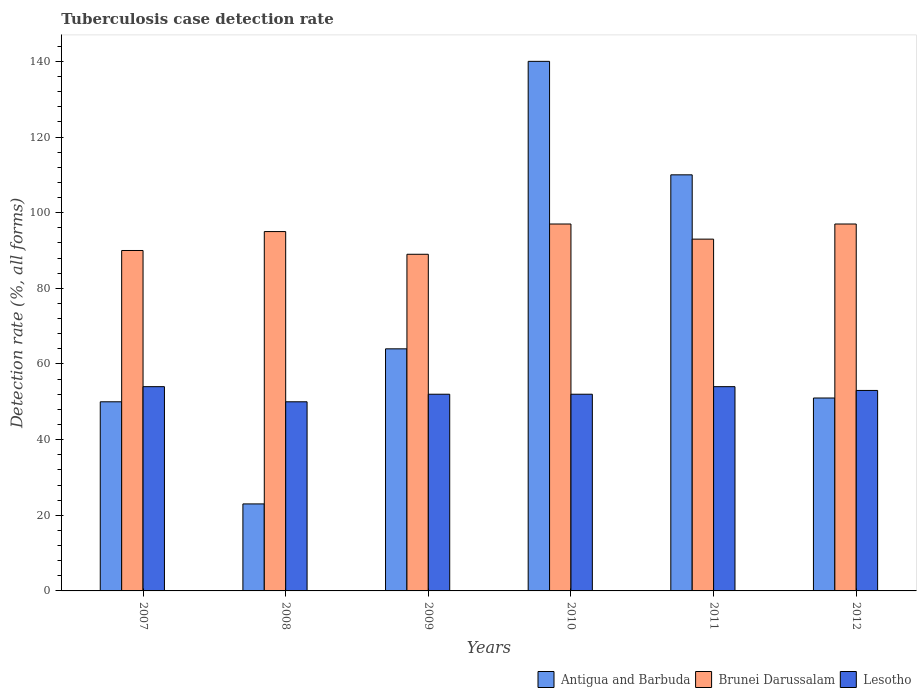How many different coloured bars are there?
Make the answer very short. 3. How many groups of bars are there?
Your answer should be compact. 6. Are the number of bars on each tick of the X-axis equal?
Offer a very short reply. Yes. How many bars are there on the 4th tick from the left?
Your response must be concise. 3. How many bars are there on the 3rd tick from the right?
Ensure brevity in your answer.  3. What is the label of the 1st group of bars from the left?
Give a very brief answer. 2007. In how many cases, is the number of bars for a given year not equal to the number of legend labels?
Your answer should be compact. 0. What is the tuberculosis case detection rate in in Lesotho in 2010?
Give a very brief answer. 52. Across all years, what is the maximum tuberculosis case detection rate in in Brunei Darussalam?
Make the answer very short. 97. Across all years, what is the minimum tuberculosis case detection rate in in Brunei Darussalam?
Keep it short and to the point. 89. In which year was the tuberculosis case detection rate in in Lesotho minimum?
Your response must be concise. 2008. What is the total tuberculosis case detection rate in in Antigua and Barbuda in the graph?
Ensure brevity in your answer.  438. What is the difference between the tuberculosis case detection rate in in Antigua and Barbuda in 2011 and that in 2012?
Give a very brief answer. 59. What is the difference between the tuberculosis case detection rate in in Lesotho in 2010 and the tuberculosis case detection rate in in Antigua and Barbuda in 2009?
Your answer should be very brief. -12. What is the average tuberculosis case detection rate in in Antigua and Barbuda per year?
Ensure brevity in your answer.  73. In the year 2008, what is the difference between the tuberculosis case detection rate in in Antigua and Barbuda and tuberculosis case detection rate in in Brunei Darussalam?
Your response must be concise. -72. What is the ratio of the tuberculosis case detection rate in in Brunei Darussalam in 2009 to that in 2010?
Keep it short and to the point. 0.92. Is the tuberculosis case detection rate in in Lesotho in 2009 less than that in 2012?
Provide a succinct answer. Yes. Is the difference between the tuberculosis case detection rate in in Antigua and Barbuda in 2010 and 2011 greater than the difference between the tuberculosis case detection rate in in Brunei Darussalam in 2010 and 2011?
Your answer should be very brief. Yes. What is the difference between the highest and the second highest tuberculosis case detection rate in in Brunei Darussalam?
Make the answer very short. 0. What is the difference between the highest and the lowest tuberculosis case detection rate in in Antigua and Barbuda?
Make the answer very short. 117. Is the sum of the tuberculosis case detection rate in in Brunei Darussalam in 2008 and 2010 greater than the maximum tuberculosis case detection rate in in Lesotho across all years?
Provide a succinct answer. Yes. What does the 1st bar from the left in 2012 represents?
Offer a very short reply. Antigua and Barbuda. What does the 1st bar from the right in 2009 represents?
Give a very brief answer. Lesotho. Is it the case that in every year, the sum of the tuberculosis case detection rate in in Antigua and Barbuda and tuberculosis case detection rate in in Brunei Darussalam is greater than the tuberculosis case detection rate in in Lesotho?
Keep it short and to the point. Yes. How many bars are there?
Offer a terse response. 18. How many years are there in the graph?
Provide a succinct answer. 6. What is the difference between two consecutive major ticks on the Y-axis?
Offer a terse response. 20. Are the values on the major ticks of Y-axis written in scientific E-notation?
Your response must be concise. No. Does the graph contain grids?
Provide a short and direct response. No. Where does the legend appear in the graph?
Your answer should be compact. Bottom right. How many legend labels are there?
Your answer should be compact. 3. How are the legend labels stacked?
Provide a short and direct response. Horizontal. What is the title of the graph?
Offer a very short reply. Tuberculosis case detection rate. Does "Uruguay" appear as one of the legend labels in the graph?
Provide a succinct answer. No. What is the label or title of the Y-axis?
Your response must be concise. Detection rate (%, all forms). What is the Detection rate (%, all forms) of Antigua and Barbuda in 2007?
Your response must be concise. 50. What is the Detection rate (%, all forms) in Lesotho in 2007?
Your response must be concise. 54. What is the Detection rate (%, all forms) in Brunei Darussalam in 2008?
Give a very brief answer. 95. What is the Detection rate (%, all forms) of Antigua and Barbuda in 2009?
Give a very brief answer. 64. What is the Detection rate (%, all forms) of Brunei Darussalam in 2009?
Give a very brief answer. 89. What is the Detection rate (%, all forms) in Lesotho in 2009?
Offer a terse response. 52. What is the Detection rate (%, all forms) in Antigua and Barbuda in 2010?
Make the answer very short. 140. What is the Detection rate (%, all forms) in Brunei Darussalam in 2010?
Your answer should be compact. 97. What is the Detection rate (%, all forms) of Lesotho in 2010?
Ensure brevity in your answer.  52. What is the Detection rate (%, all forms) of Antigua and Barbuda in 2011?
Your answer should be compact. 110. What is the Detection rate (%, all forms) of Brunei Darussalam in 2011?
Provide a short and direct response. 93. What is the Detection rate (%, all forms) of Antigua and Barbuda in 2012?
Keep it short and to the point. 51. What is the Detection rate (%, all forms) of Brunei Darussalam in 2012?
Your answer should be very brief. 97. What is the Detection rate (%, all forms) of Lesotho in 2012?
Give a very brief answer. 53. Across all years, what is the maximum Detection rate (%, all forms) in Antigua and Barbuda?
Make the answer very short. 140. Across all years, what is the maximum Detection rate (%, all forms) in Brunei Darussalam?
Make the answer very short. 97. Across all years, what is the minimum Detection rate (%, all forms) in Antigua and Barbuda?
Make the answer very short. 23. Across all years, what is the minimum Detection rate (%, all forms) of Brunei Darussalam?
Make the answer very short. 89. Across all years, what is the minimum Detection rate (%, all forms) in Lesotho?
Ensure brevity in your answer.  50. What is the total Detection rate (%, all forms) in Antigua and Barbuda in the graph?
Offer a very short reply. 438. What is the total Detection rate (%, all forms) in Brunei Darussalam in the graph?
Ensure brevity in your answer.  561. What is the total Detection rate (%, all forms) in Lesotho in the graph?
Keep it short and to the point. 315. What is the difference between the Detection rate (%, all forms) in Brunei Darussalam in 2007 and that in 2008?
Provide a short and direct response. -5. What is the difference between the Detection rate (%, all forms) of Lesotho in 2007 and that in 2008?
Your answer should be compact. 4. What is the difference between the Detection rate (%, all forms) in Brunei Darussalam in 2007 and that in 2009?
Your answer should be compact. 1. What is the difference between the Detection rate (%, all forms) of Antigua and Barbuda in 2007 and that in 2010?
Provide a short and direct response. -90. What is the difference between the Detection rate (%, all forms) in Antigua and Barbuda in 2007 and that in 2011?
Your answer should be compact. -60. What is the difference between the Detection rate (%, all forms) of Brunei Darussalam in 2007 and that in 2011?
Your answer should be very brief. -3. What is the difference between the Detection rate (%, all forms) in Lesotho in 2007 and that in 2011?
Keep it short and to the point. 0. What is the difference between the Detection rate (%, all forms) in Antigua and Barbuda in 2008 and that in 2009?
Offer a very short reply. -41. What is the difference between the Detection rate (%, all forms) of Antigua and Barbuda in 2008 and that in 2010?
Provide a succinct answer. -117. What is the difference between the Detection rate (%, all forms) of Lesotho in 2008 and that in 2010?
Give a very brief answer. -2. What is the difference between the Detection rate (%, all forms) of Antigua and Barbuda in 2008 and that in 2011?
Ensure brevity in your answer.  -87. What is the difference between the Detection rate (%, all forms) of Brunei Darussalam in 2008 and that in 2011?
Offer a terse response. 2. What is the difference between the Detection rate (%, all forms) of Lesotho in 2008 and that in 2011?
Give a very brief answer. -4. What is the difference between the Detection rate (%, all forms) in Lesotho in 2008 and that in 2012?
Keep it short and to the point. -3. What is the difference between the Detection rate (%, all forms) in Antigua and Barbuda in 2009 and that in 2010?
Offer a very short reply. -76. What is the difference between the Detection rate (%, all forms) of Brunei Darussalam in 2009 and that in 2010?
Ensure brevity in your answer.  -8. What is the difference between the Detection rate (%, all forms) in Antigua and Barbuda in 2009 and that in 2011?
Provide a short and direct response. -46. What is the difference between the Detection rate (%, all forms) of Lesotho in 2009 and that in 2011?
Your answer should be compact. -2. What is the difference between the Detection rate (%, all forms) of Antigua and Barbuda in 2009 and that in 2012?
Offer a terse response. 13. What is the difference between the Detection rate (%, all forms) in Brunei Darussalam in 2009 and that in 2012?
Your response must be concise. -8. What is the difference between the Detection rate (%, all forms) of Antigua and Barbuda in 2010 and that in 2011?
Your answer should be compact. 30. What is the difference between the Detection rate (%, all forms) in Brunei Darussalam in 2010 and that in 2011?
Your answer should be very brief. 4. What is the difference between the Detection rate (%, all forms) in Lesotho in 2010 and that in 2011?
Keep it short and to the point. -2. What is the difference between the Detection rate (%, all forms) of Antigua and Barbuda in 2010 and that in 2012?
Ensure brevity in your answer.  89. What is the difference between the Detection rate (%, all forms) in Brunei Darussalam in 2010 and that in 2012?
Keep it short and to the point. 0. What is the difference between the Detection rate (%, all forms) in Antigua and Barbuda in 2007 and the Detection rate (%, all forms) in Brunei Darussalam in 2008?
Your response must be concise. -45. What is the difference between the Detection rate (%, all forms) in Antigua and Barbuda in 2007 and the Detection rate (%, all forms) in Brunei Darussalam in 2009?
Your answer should be compact. -39. What is the difference between the Detection rate (%, all forms) in Antigua and Barbuda in 2007 and the Detection rate (%, all forms) in Brunei Darussalam in 2010?
Offer a very short reply. -47. What is the difference between the Detection rate (%, all forms) of Antigua and Barbuda in 2007 and the Detection rate (%, all forms) of Lesotho in 2010?
Keep it short and to the point. -2. What is the difference between the Detection rate (%, all forms) of Brunei Darussalam in 2007 and the Detection rate (%, all forms) of Lesotho in 2010?
Provide a short and direct response. 38. What is the difference between the Detection rate (%, all forms) of Antigua and Barbuda in 2007 and the Detection rate (%, all forms) of Brunei Darussalam in 2011?
Provide a succinct answer. -43. What is the difference between the Detection rate (%, all forms) of Antigua and Barbuda in 2007 and the Detection rate (%, all forms) of Brunei Darussalam in 2012?
Ensure brevity in your answer.  -47. What is the difference between the Detection rate (%, all forms) in Antigua and Barbuda in 2007 and the Detection rate (%, all forms) in Lesotho in 2012?
Offer a terse response. -3. What is the difference between the Detection rate (%, all forms) of Antigua and Barbuda in 2008 and the Detection rate (%, all forms) of Brunei Darussalam in 2009?
Offer a very short reply. -66. What is the difference between the Detection rate (%, all forms) in Antigua and Barbuda in 2008 and the Detection rate (%, all forms) in Lesotho in 2009?
Keep it short and to the point. -29. What is the difference between the Detection rate (%, all forms) in Brunei Darussalam in 2008 and the Detection rate (%, all forms) in Lesotho in 2009?
Make the answer very short. 43. What is the difference between the Detection rate (%, all forms) of Antigua and Barbuda in 2008 and the Detection rate (%, all forms) of Brunei Darussalam in 2010?
Your answer should be compact. -74. What is the difference between the Detection rate (%, all forms) of Antigua and Barbuda in 2008 and the Detection rate (%, all forms) of Lesotho in 2010?
Your answer should be compact. -29. What is the difference between the Detection rate (%, all forms) of Antigua and Barbuda in 2008 and the Detection rate (%, all forms) of Brunei Darussalam in 2011?
Keep it short and to the point. -70. What is the difference between the Detection rate (%, all forms) of Antigua and Barbuda in 2008 and the Detection rate (%, all forms) of Lesotho in 2011?
Keep it short and to the point. -31. What is the difference between the Detection rate (%, all forms) in Brunei Darussalam in 2008 and the Detection rate (%, all forms) in Lesotho in 2011?
Make the answer very short. 41. What is the difference between the Detection rate (%, all forms) in Antigua and Barbuda in 2008 and the Detection rate (%, all forms) in Brunei Darussalam in 2012?
Keep it short and to the point. -74. What is the difference between the Detection rate (%, all forms) of Antigua and Barbuda in 2008 and the Detection rate (%, all forms) of Lesotho in 2012?
Ensure brevity in your answer.  -30. What is the difference between the Detection rate (%, all forms) in Antigua and Barbuda in 2009 and the Detection rate (%, all forms) in Brunei Darussalam in 2010?
Keep it short and to the point. -33. What is the difference between the Detection rate (%, all forms) in Antigua and Barbuda in 2009 and the Detection rate (%, all forms) in Lesotho in 2010?
Make the answer very short. 12. What is the difference between the Detection rate (%, all forms) in Brunei Darussalam in 2009 and the Detection rate (%, all forms) in Lesotho in 2010?
Give a very brief answer. 37. What is the difference between the Detection rate (%, all forms) in Antigua and Barbuda in 2009 and the Detection rate (%, all forms) in Lesotho in 2011?
Your answer should be compact. 10. What is the difference between the Detection rate (%, all forms) in Brunei Darussalam in 2009 and the Detection rate (%, all forms) in Lesotho in 2011?
Your response must be concise. 35. What is the difference between the Detection rate (%, all forms) of Antigua and Barbuda in 2009 and the Detection rate (%, all forms) of Brunei Darussalam in 2012?
Make the answer very short. -33. What is the difference between the Detection rate (%, all forms) in Antigua and Barbuda in 2010 and the Detection rate (%, all forms) in Brunei Darussalam in 2011?
Your answer should be very brief. 47. What is the difference between the Detection rate (%, all forms) in Antigua and Barbuda in 2010 and the Detection rate (%, all forms) in Lesotho in 2011?
Ensure brevity in your answer.  86. What is the difference between the Detection rate (%, all forms) of Brunei Darussalam in 2010 and the Detection rate (%, all forms) of Lesotho in 2011?
Keep it short and to the point. 43. What is the difference between the Detection rate (%, all forms) of Antigua and Barbuda in 2010 and the Detection rate (%, all forms) of Brunei Darussalam in 2012?
Your answer should be compact. 43. What is the difference between the Detection rate (%, all forms) in Antigua and Barbuda in 2011 and the Detection rate (%, all forms) in Brunei Darussalam in 2012?
Your answer should be very brief. 13. What is the difference between the Detection rate (%, all forms) of Antigua and Barbuda in 2011 and the Detection rate (%, all forms) of Lesotho in 2012?
Keep it short and to the point. 57. What is the average Detection rate (%, all forms) of Brunei Darussalam per year?
Your answer should be very brief. 93.5. What is the average Detection rate (%, all forms) in Lesotho per year?
Give a very brief answer. 52.5. In the year 2007, what is the difference between the Detection rate (%, all forms) in Antigua and Barbuda and Detection rate (%, all forms) in Lesotho?
Your answer should be very brief. -4. In the year 2007, what is the difference between the Detection rate (%, all forms) in Brunei Darussalam and Detection rate (%, all forms) in Lesotho?
Offer a very short reply. 36. In the year 2008, what is the difference between the Detection rate (%, all forms) of Antigua and Barbuda and Detection rate (%, all forms) of Brunei Darussalam?
Keep it short and to the point. -72. In the year 2009, what is the difference between the Detection rate (%, all forms) of Brunei Darussalam and Detection rate (%, all forms) of Lesotho?
Make the answer very short. 37. In the year 2010, what is the difference between the Detection rate (%, all forms) in Antigua and Barbuda and Detection rate (%, all forms) in Lesotho?
Your response must be concise. 88. In the year 2011, what is the difference between the Detection rate (%, all forms) in Antigua and Barbuda and Detection rate (%, all forms) in Lesotho?
Your response must be concise. 56. In the year 2011, what is the difference between the Detection rate (%, all forms) in Brunei Darussalam and Detection rate (%, all forms) in Lesotho?
Give a very brief answer. 39. In the year 2012, what is the difference between the Detection rate (%, all forms) of Antigua and Barbuda and Detection rate (%, all forms) of Brunei Darussalam?
Your answer should be compact. -46. In the year 2012, what is the difference between the Detection rate (%, all forms) of Antigua and Barbuda and Detection rate (%, all forms) of Lesotho?
Keep it short and to the point. -2. What is the ratio of the Detection rate (%, all forms) in Antigua and Barbuda in 2007 to that in 2008?
Ensure brevity in your answer.  2.17. What is the ratio of the Detection rate (%, all forms) in Antigua and Barbuda in 2007 to that in 2009?
Your response must be concise. 0.78. What is the ratio of the Detection rate (%, all forms) in Brunei Darussalam in 2007 to that in 2009?
Your answer should be very brief. 1.01. What is the ratio of the Detection rate (%, all forms) in Lesotho in 2007 to that in 2009?
Your answer should be compact. 1.04. What is the ratio of the Detection rate (%, all forms) in Antigua and Barbuda in 2007 to that in 2010?
Offer a very short reply. 0.36. What is the ratio of the Detection rate (%, all forms) of Brunei Darussalam in 2007 to that in 2010?
Give a very brief answer. 0.93. What is the ratio of the Detection rate (%, all forms) of Lesotho in 2007 to that in 2010?
Offer a very short reply. 1.04. What is the ratio of the Detection rate (%, all forms) in Antigua and Barbuda in 2007 to that in 2011?
Offer a terse response. 0.45. What is the ratio of the Detection rate (%, all forms) in Lesotho in 2007 to that in 2011?
Give a very brief answer. 1. What is the ratio of the Detection rate (%, all forms) in Antigua and Barbuda in 2007 to that in 2012?
Offer a terse response. 0.98. What is the ratio of the Detection rate (%, all forms) of Brunei Darussalam in 2007 to that in 2012?
Provide a succinct answer. 0.93. What is the ratio of the Detection rate (%, all forms) of Lesotho in 2007 to that in 2012?
Keep it short and to the point. 1.02. What is the ratio of the Detection rate (%, all forms) in Antigua and Barbuda in 2008 to that in 2009?
Offer a very short reply. 0.36. What is the ratio of the Detection rate (%, all forms) of Brunei Darussalam in 2008 to that in 2009?
Ensure brevity in your answer.  1.07. What is the ratio of the Detection rate (%, all forms) of Lesotho in 2008 to that in 2009?
Make the answer very short. 0.96. What is the ratio of the Detection rate (%, all forms) in Antigua and Barbuda in 2008 to that in 2010?
Offer a terse response. 0.16. What is the ratio of the Detection rate (%, all forms) of Brunei Darussalam in 2008 to that in 2010?
Provide a short and direct response. 0.98. What is the ratio of the Detection rate (%, all forms) in Lesotho in 2008 to that in 2010?
Your response must be concise. 0.96. What is the ratio of the Detection rate (%, all forms) of Antigua and Barbuda in 2008 to that in 2011?
Offer a terse response. 0.21. What is the ratio of the Detection rate (%, all forms) of Brunei Darussalam in 2008 to that in 2011?
Provide a succinct answer. 1.02. What is the ratio of the Detection rate (%, all forms) of Lesotho in 2008 to that in 2011?
Make the answer very short. 0.93. What is the ratio of the Detection rate (%, all forms) in Antigua and Barbuda in 2008 to that in 2012?
Ensure brevity in your answer.  0.45. What is the ratio of the Detection rate (%, all forms) of Brunei Darussalam in 2008 to that in 2012?
Your answer should be compact. 0.98. What is the ratio of the Detection rate (%, all forms) in Lesotho in 2008 to that in 2012?
Provide a short and direct response. 0.94. What is the ratio of the Detection rate (%, all forms) in Antigua and Barbuda in 2009 to that in 2010?
Your response must be concise. 0.46. What is the ratio of the Detection rate (%, all forms) of Brunei Darussalam in 2009 to that in 2010?
Offer a terse response. 0.92. What is the ratio of the Detection rate (%, all forms) in Lesotho in 2009 to that in 2010?
Ensure brevity in your answer.  1. What is the ratio of the Detection rate (%, all forms) of Antigua and Barbuda in 2009 to that in 2011?
Make the answer very short. 0.58. What is the ratio of the Detection rate (%, all forms) of Lesotho in 2009 to that in 2011?
Ensure brevity in your answer.  0.96. What is the ratio of the Detection rate (%, all forms) in Antigua and Barbuda in 2009 to that in 2012?
Offer a very short reply. 1.25. What is the ratio of the Detection rate (%, all forms) of Brunei Darussalam in 2009 to that in 2012?
Give a very brief answer. 0.92. What is the ratio of the Detection rate (%, all forms) in Lesotho in 2009 to that in 2012?
Keep it short and to the point. 0.98. What is the ratio of the Detection rate (%, all forms) of Antigua and Barbuda in 2010 to that in 2011?
Ensure brevity in your answer.  1.27. What is the ratio of the Detection rate (%, all forms) of Brunei Darussalam in 2010 to that in 2011?
Offer a terse response. 1.04. What is the ratio of the Detection rate (%, all forms) in Antigua and Barbuda in 2010 to that in 2012?
Give a very brief answer. 2.75. What is the ratio of the Detection rate (%, all forms) of Brunei Darussalam in 2010 to that in 2012?
Provide a short and direct response. 1. What is the ratio of the Detection rate (%, all forms) in Lesotho in 2010 to that in 2012?
Your response must be concise. 0.98. What is the ratio of the Detection rate (%, all forms) in Antigua and Barbuda in 2011 to that in 2012?
Ensure brevity in your answer.  2.16. What is the ratio of the Detection rate (%, all forms) of Brunei Darussalam in 2011 to that in 2012?
Keep it short and to the point. 0.96. What is the ratio of the Detection rate (%, all forms) of Lesotho in 2011 to that in 2012?
Provide a short and direct response. 1.02. What is the difference between the highest and the second highest Detection rate (%, all forms) in Antigua and Barbuda?
Your answer should be very brief. 30. What is the difference between the highest and the second highest Detection rate (%, all forms) of Lesotho?
Your answer should be compact. 0. What is the difference between the highest and the lowest Detection rate (%, all forms) of Antigua and Barbuda?
Offer a terse response. 117. What is the difference between the highest and the lowest Detection rate (%, all forms) in Lesotho?
Provide a short and direct response. 4. 